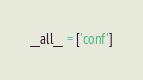Convert code to text. <code><loc_0><loc_0><loc_500><loc_500><_Python_>__all__ = ['conf']</code> 